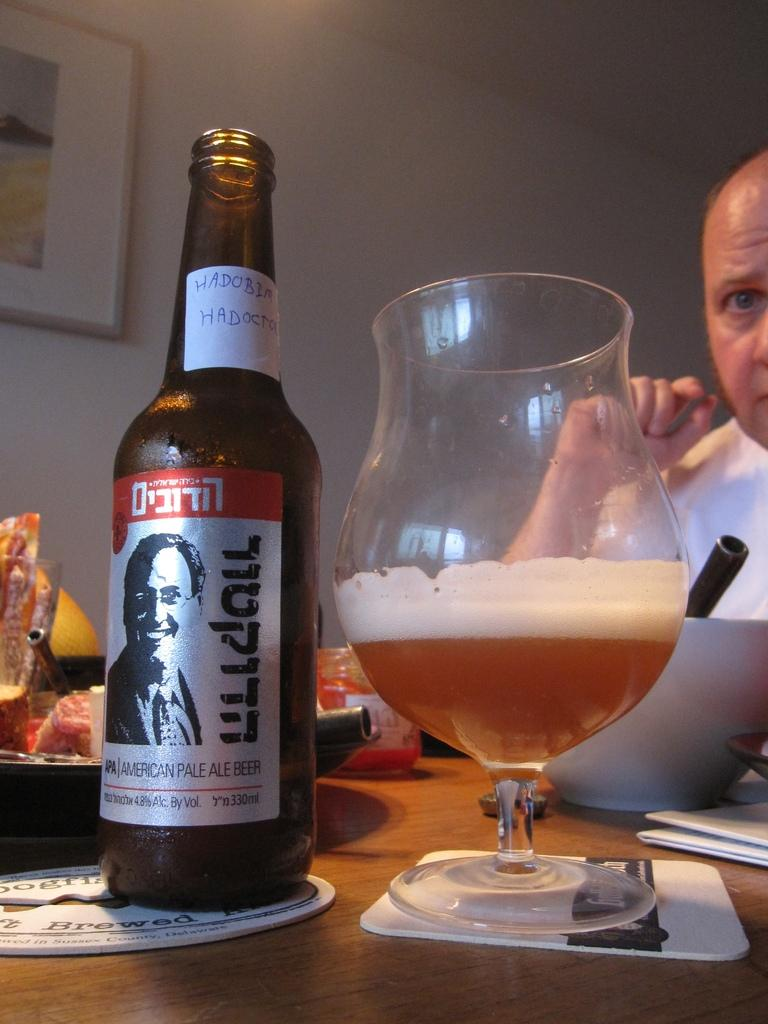<image>
Relay a brief, clear account of the picture shown. A bottle of Ladobin beer poured into a glass. 